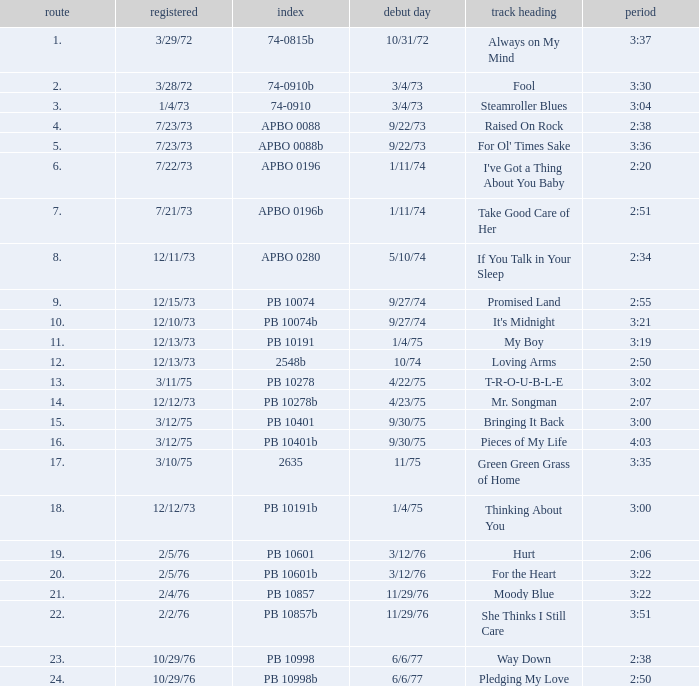Tell me the release date record on 10/29/76 and a time on 2:50 6/6/77. 